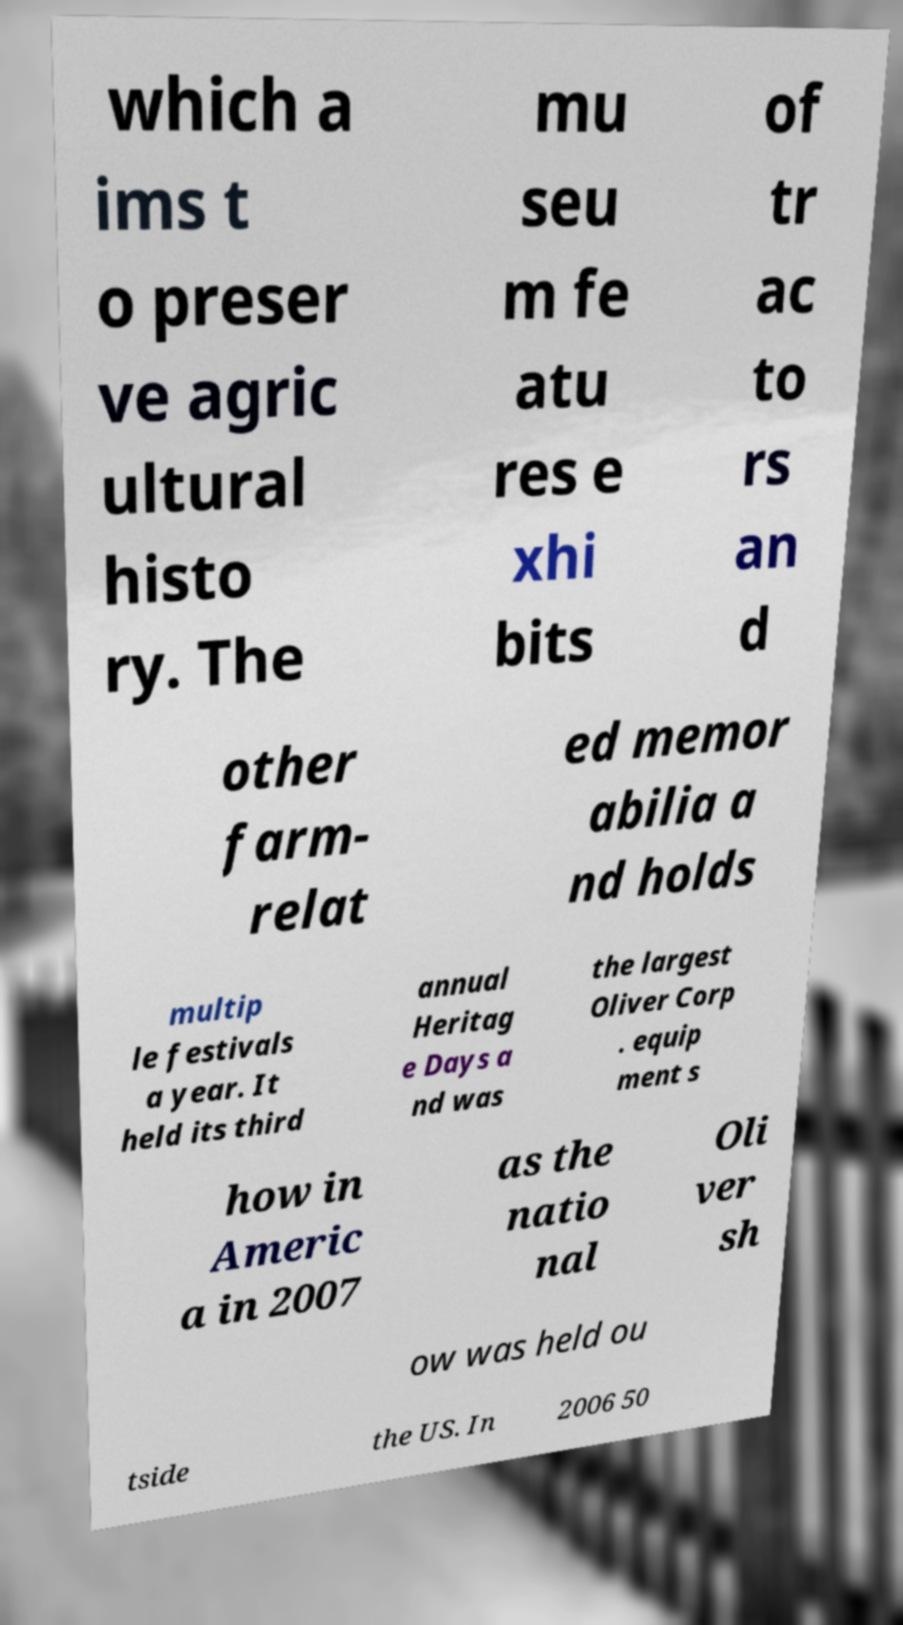For documentation purposes, I need the text within this image transcribed. Could you provide that? which a ims t o preser ve agric ultural histo ry. The mu seu m fe atu res e xhi bits of tr ac to rs an d other farm- relat ed memor abilia a nd holds multip le festivals a year. It held its third annual Heritag e Days a nd was the largest Oliver Corp . equip ment s how in Americ a in 2007 as the natio nal Oli ver sh ow was held ou tside the US. In 2006 50 